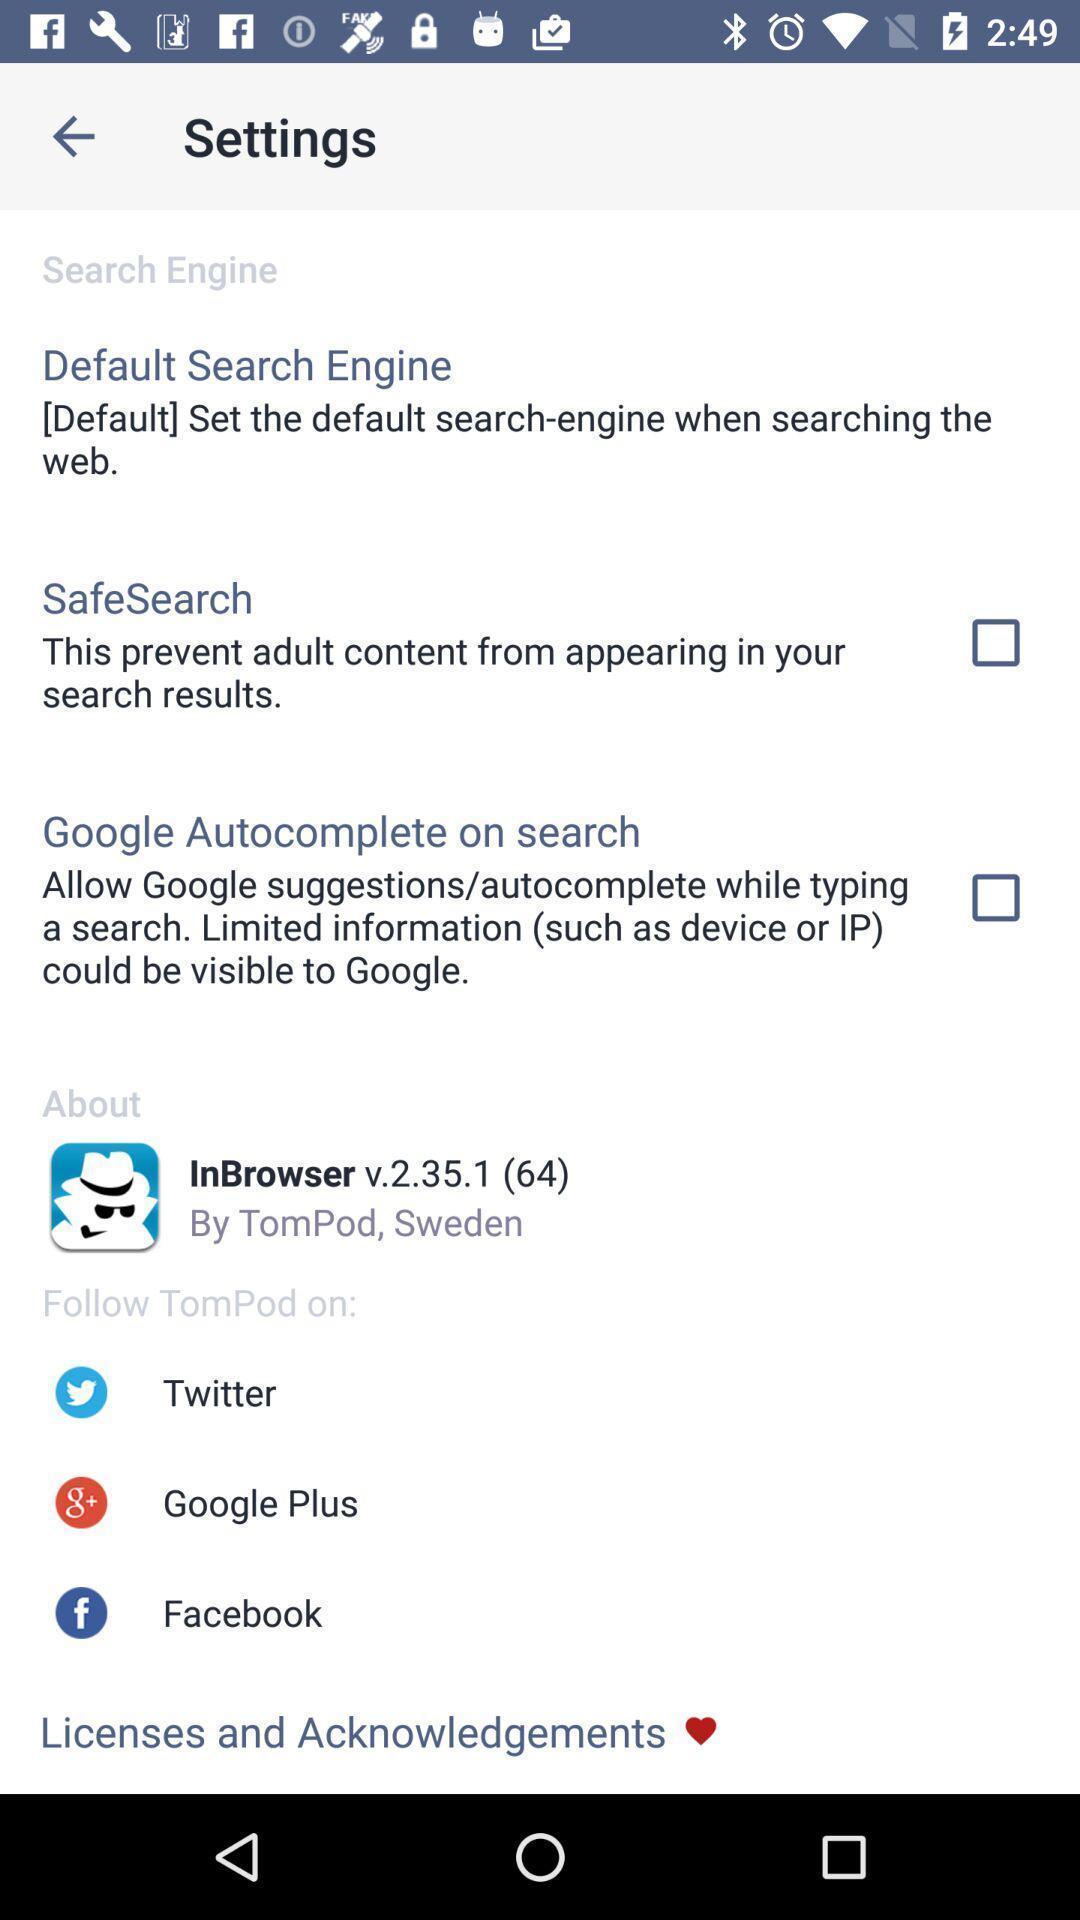Give me a narrative description of this picture. Setting page displaying the various options. 